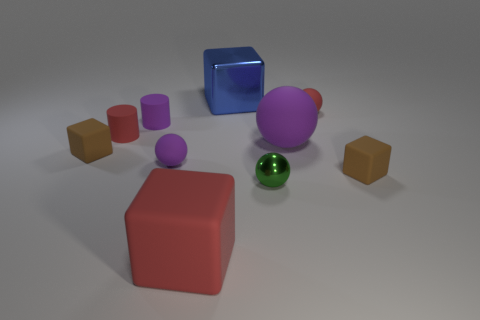Are there any cylinders to the right of the large matte block?
Provide a short and direct response. No. How many objects are either red rubber things behind the red rubber cylinder or rubber spheres?
Ensure brevity in your answer.  3. What size is the blue block that is the same material as the green thing?
Offer a very short reply. Large. There is a metal ball; is its size the same as the block left of the purple matte cylinder?
Give a very brief answer. Yes. What color is the matte cube that is both behind the red block and left of the small green ball?
Your response must be concise. Brown. How many things are tiny cylinders behind the red rubber cylinder or tiny purple things on the left side of the small purple sphere?
Provide a succinct answer. 1. What color is the small ball in front of the brown matte thing on the right side of the small red rubber thing right of the green sphere?
Your answer should be very brief. Green. Is there a purple matte thing of the same shape as the green object?
Your answer should be very brief. Yes. What number of small matte things are there?
Make the answer very short. 6. What is the shape of the blue metal thing?
Provide a short and direct response. Cube. 